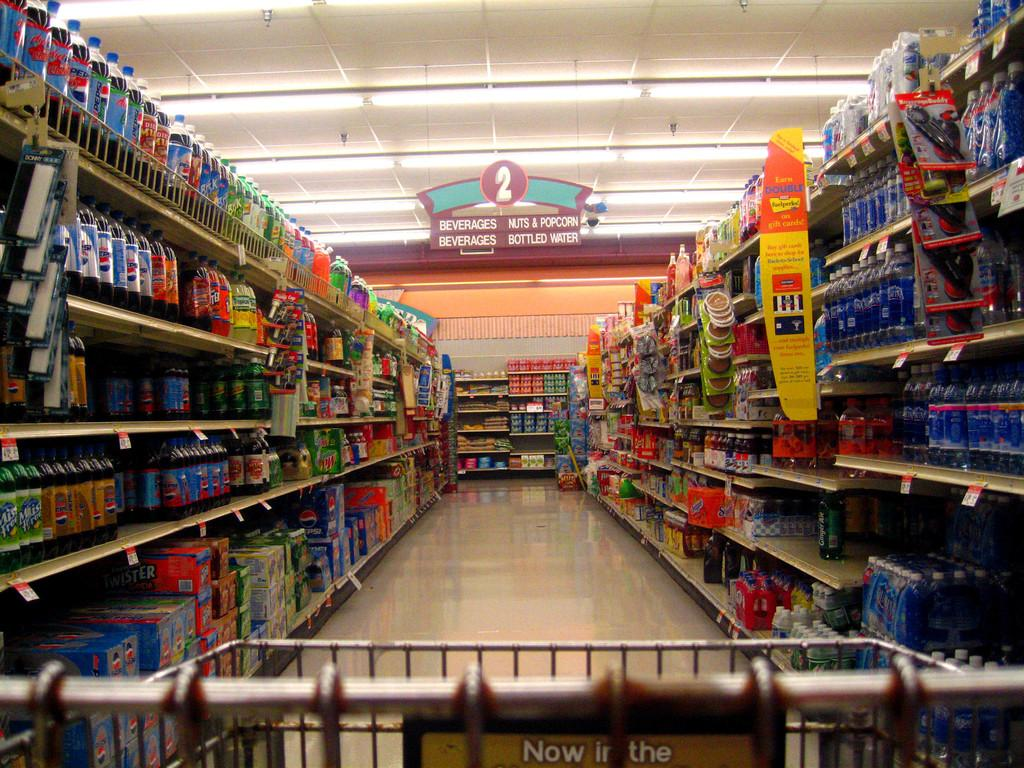<image>
Write a terse but informative summary of the picture. Person in an aisle that says Bottled Water is available. 